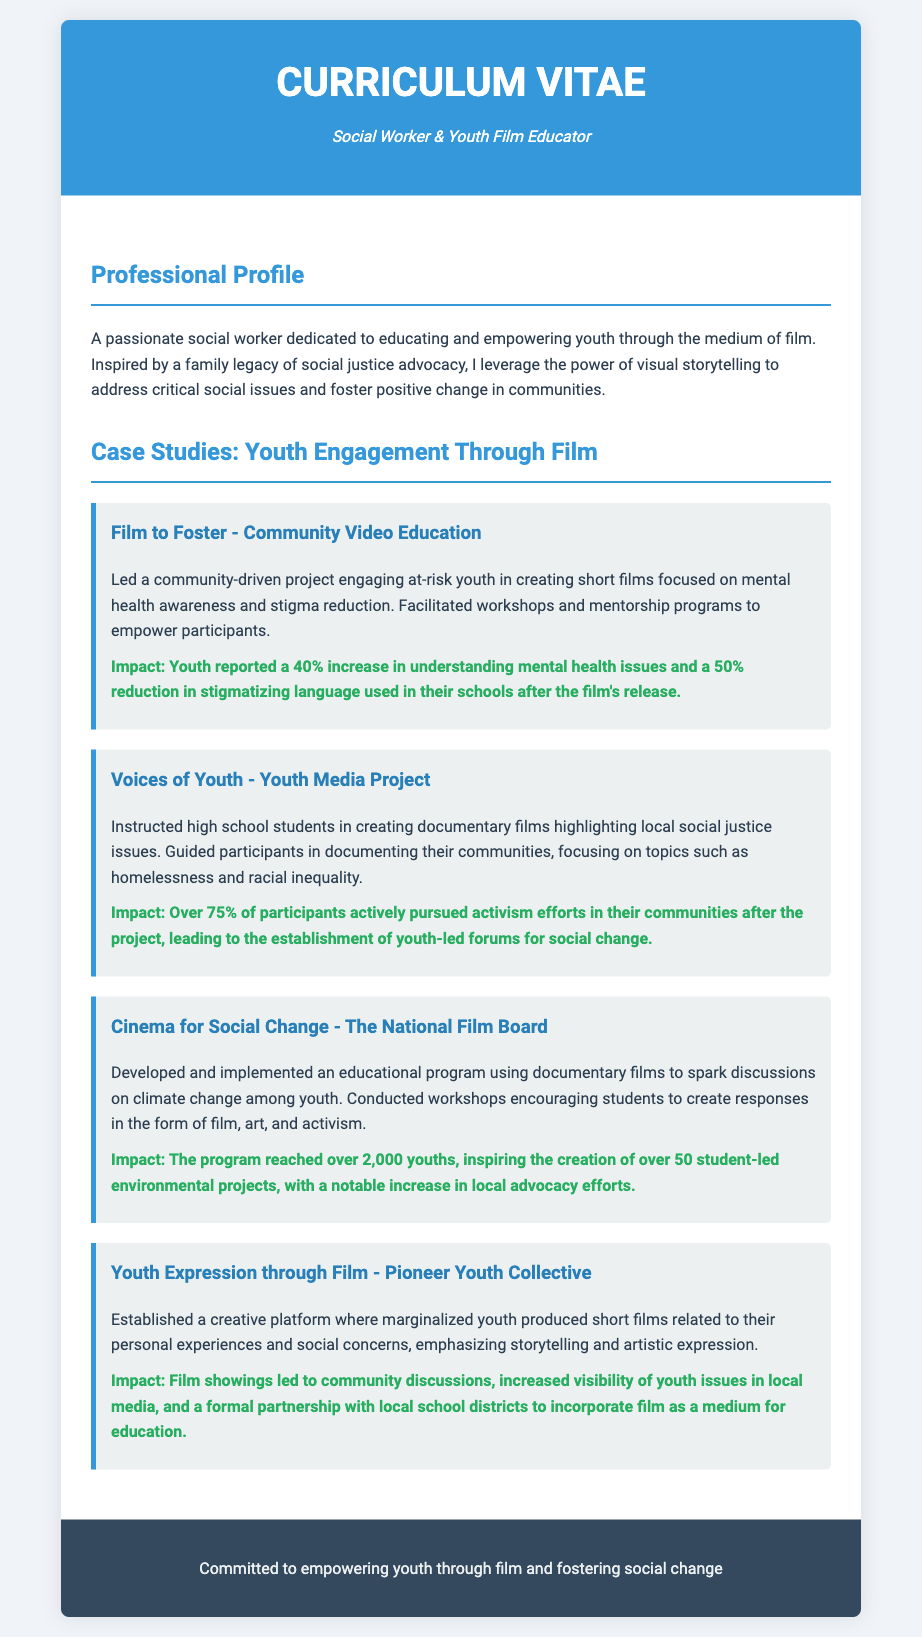What is the title of the document? The title of the document is specified in the header section of the CV as "Curriculum Vitae - Social Worker & Youth Film Educator."
Answer: Curriculum Vitae - Social Worker & Youth Film Educator What is the name of the first case study? The first case study is mentioned in the document as "Film to Foster - Community Video Education."
Answer: Film to Foster - Community Video Education What percentage increase in understanding mental health issues was reported by youth? The document states that youth reported a 40% increase in understanding mental health issues after participating in the project.
Answer: 40% What social issues did participants focus on in the "Voices of Youth" project? The document highlights that the focus of the project included social issues such as homelessness and racial inequality.
Answer: Homelessness and racial inequality How many student-led environmental projects were inspired by the Cinema for Social Change program? According to the document, the program inspired the creation of over 50 student-led environmental projects.
Answer: Over 50 What was the impact of the Youth Expression through Film project? The document mentions that the impact included increased visibility of youth issues in local media and a formal partnership with local school districts.
Answer: Increased visibility of youth issues in local media What type of films did youth create in the "Film to Foster" project? In the "Film to Foster" project, youth created short films focused on mental health awareness and stigma reduction.
Answer: Short films focused on mental health awareness In what year was the Cinema for Social Change program implemented? The document does not specify a year for when the Cinema for Social Change program was implemented.
Answer: Not specified 